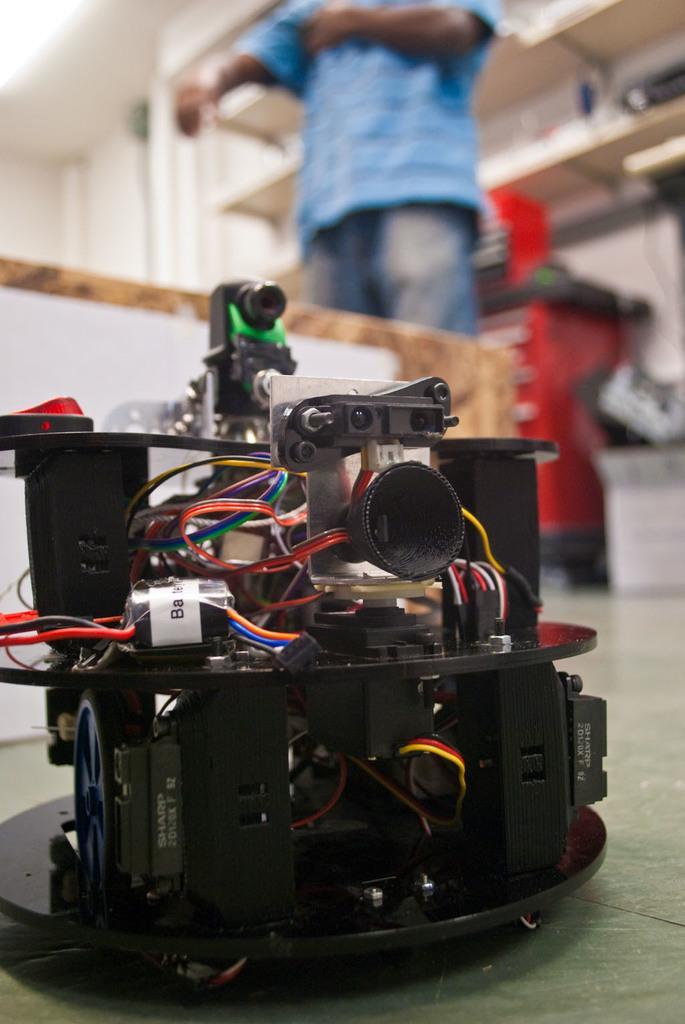In one or two sentences, can you explain what this image depicts? There is an electrical device present at the bottom of this image. We can see a person and racks at the top of this image. 